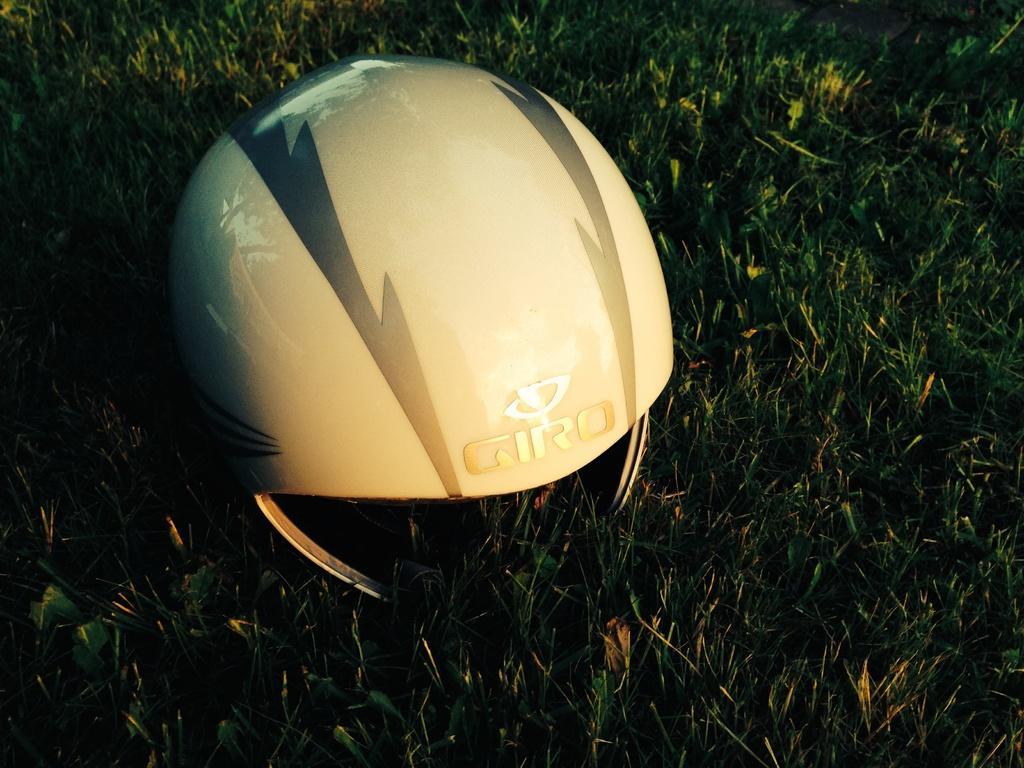Could you give a brief overview of what you see in this image? Here we can see a helmet on the ground and this is grass. 